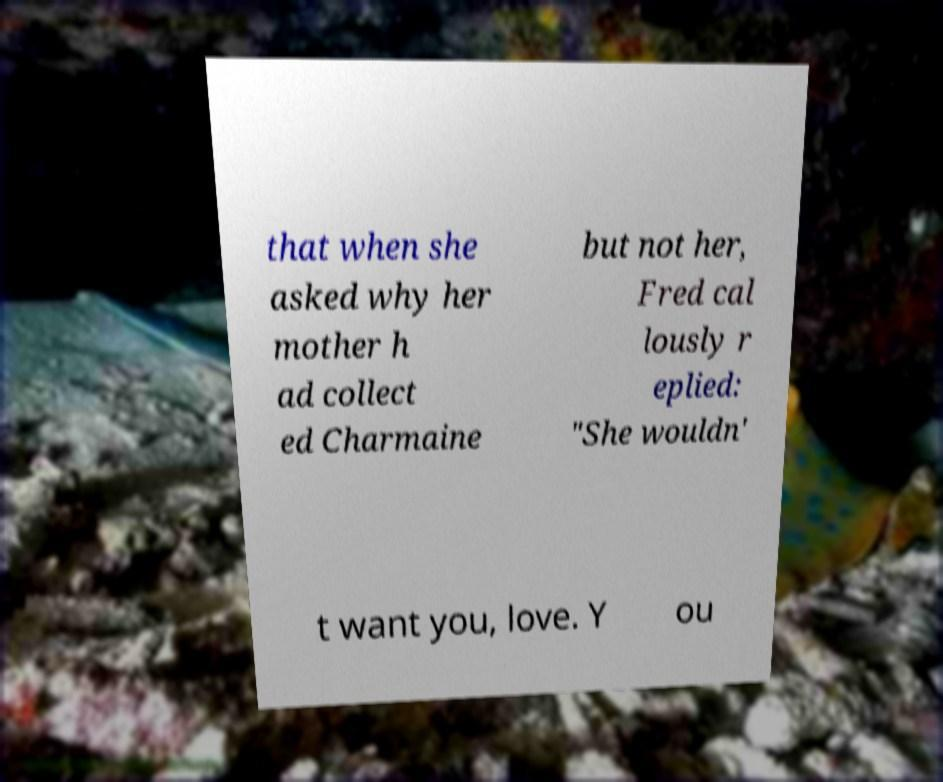Could you extract and type out the text from this image? that when she asked why her mother h ad collect ed Charmaine but not her, Fred cal lously r eplied: "She wouldn' t want you, love. Y ou 